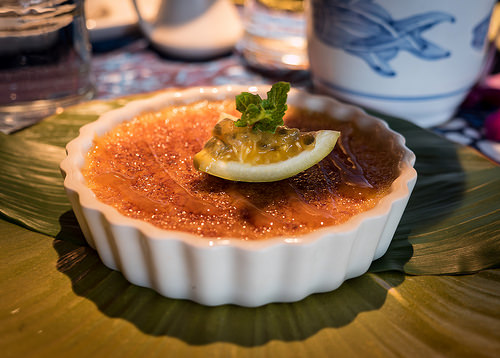<image>
Can you confirm if the lemon is on the leaf? No. The lemon is not positioned on the leaf. They may be near each other, but the lemon is not supported by or resting on top of the leaf. 